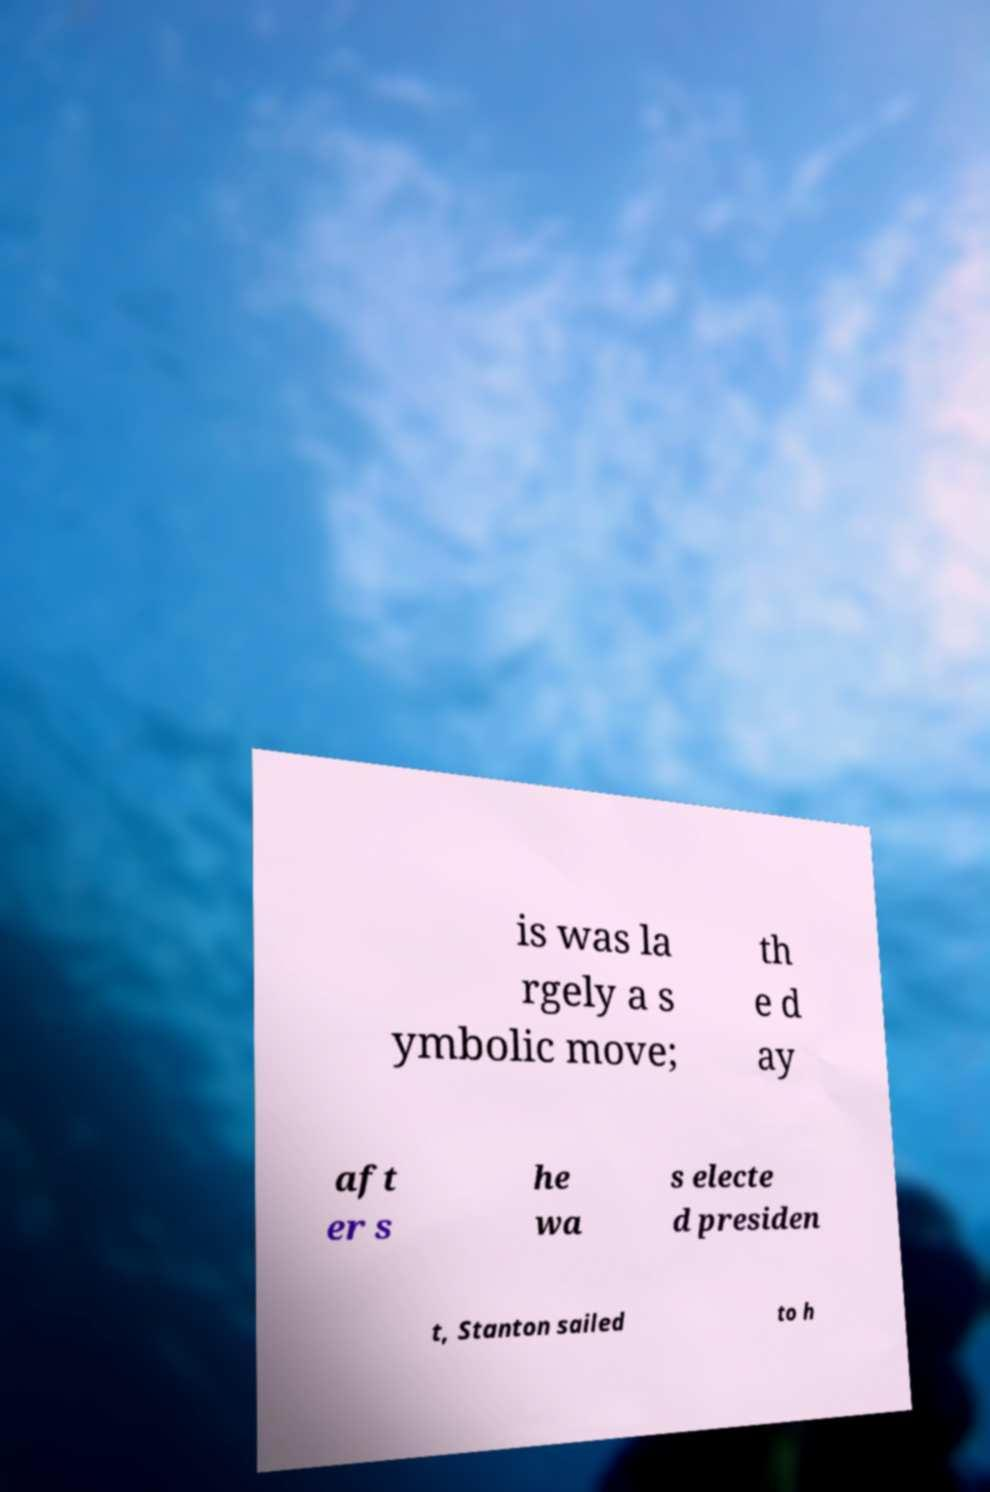Please read and relay the text visible in this image. What does it say? is was la rgely a s ymbolic move; th e d ay aft er s he wa s electe d presiden t, Stanton sailed to h 